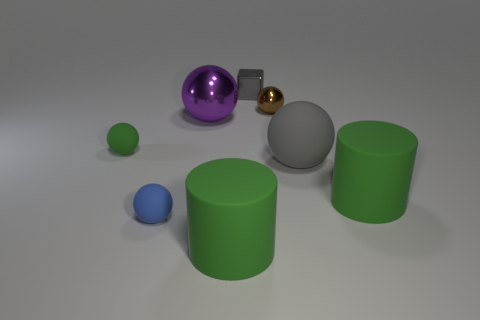Subtract all brown balls. How many balls are left? 4 Subtract all purple metal spheres. How many spheres are left? 4 Add 1 tiny objects. How many objects exist? 9 Add 4 big green matte cylinders. How many big green matte cylinders exist? 6 Subtract 0 purple cylinders. How many objects are left? 8 Subtract all blocks. How many objects are left? 7 Subtract 1 cylinders. How many cylinders are left? 1 Subtract all brown blocks. Subtract all purple cylinders. How many blocks are left? 1 Subtract all purple balls. How many yellow cylinders are left? 0 Subtract all brown things. Subtract all metal cubes. How many objects are left? 6 